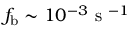<formula> <loc_0><loc_0><loc_500><loc_500>f _ { b } \sim 1 0 ^ { - 3 } s ^ { - 1 }</formula> 